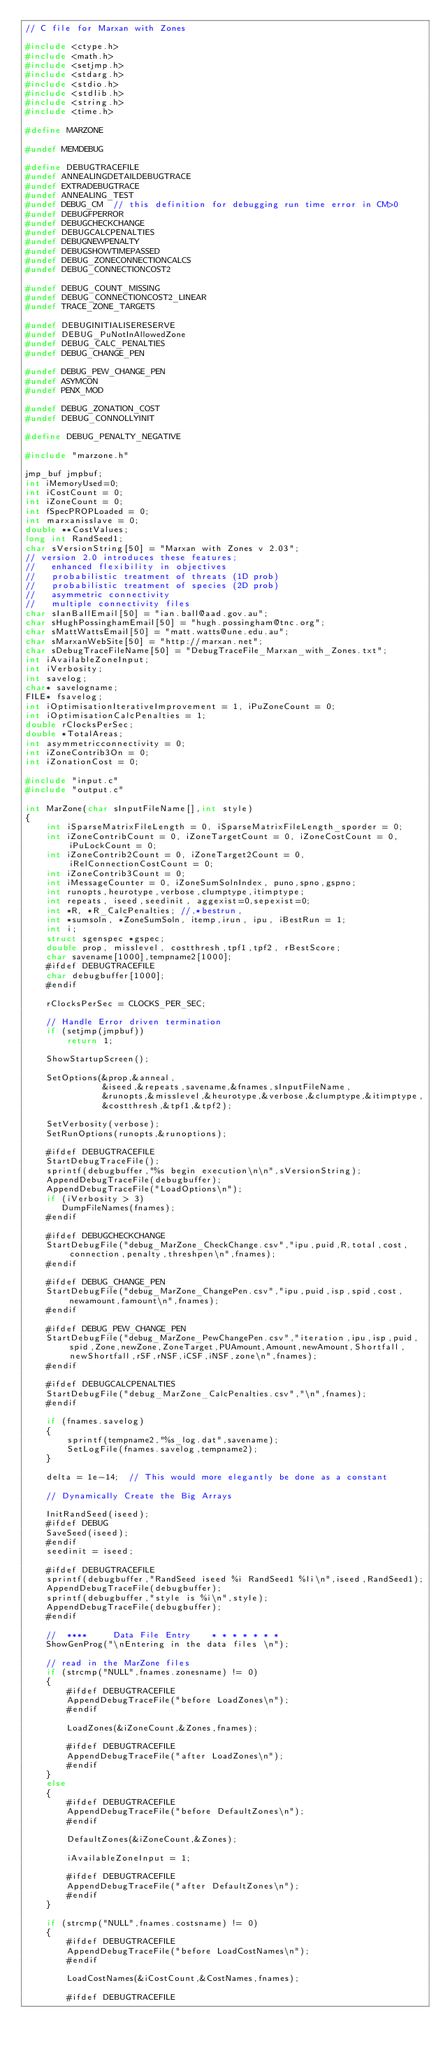Convert code to text. <code><loc_0><loc_0><loc_500><loc_500><_C_>// C file for Marxan with Zones

#include <ctype.h>
#include <math.h>
#include <setjmp.h>
#include <stdarg.h>
#include <stdio.h>
#include <stdlib.h>
#include <string.h>
#include <time.h>

#define MARZONE

#undef MEMDEBUG

#define DEBUGTRACEFILE
#undef ANNEALINGDETAILDEBUGTRACE
#undef EXTRADEBUGTRACE
#undef ANNEALING_TEST
#undef DEBUG_CM  // this definition for debugging run time error in CM>0
#undef DEBUGFPERROR
#undef DEBUGCHECKCHANGE
#undef DEBUGCALCPENALTIES
#undef DEBUGNEWPENALTY
#undef DEBUGSHOWTIMEPASSED
#undef DEBUG_ZONECONNECTIONCALCS
#undef DEBUG_CONNECTIONCOST2

#undef DEBUG_COUNT_MISSING
#undef DEBUG_CONNECTIONCOST2_LINEAR
#undef TRACE_ZONE_TARGETS

#undef DEBUGINITIALISERESERVE
#undef DEBUG_PuNotInAllowedZone
#undef DEBUG_CALC_PENALTIES
#undef DEBUG_CHANGE_PEN

#undef DEBUG_PEW_CHANGE_PEN
#undef ASYMCON
#undef PENX_MOD

#undef DEBUG_ZONATION_COST
#undef DEBUG_CONNOLLYINIT

#define DEBUG_PENALTY_NEGATIVE

#include "marzone.h"

jmp_buf jmpbuf;
int iMemoryUsed=0;
int iCostCount = 0;
int iZoneCount = 0;
int fSpecPROPLoaded = 0;
int marxanisslave = 0;
double **CostValues;
long int RandSeed1;
char sVersionString[50] = "Marxan with Zones v 2.03";
// version 2.0 introduces these features;
//   enhanced flexibility in objectives
//   probabilistic treatment of threats (1D prob)
//   probabilistic treatment of species (2D prob)
//   asymmetric connectivity
//   multiple connectivity files
char sIanBallEmail[50] = "ian.ball@aad.gov.au";
char sHughPossinghamEmail[50] = "hugh.possingham@tnc.org";
char sMattWattsEmail[50] = "matt.watts@une.edu.au";
char sMarxanWebSite[50] = "http://marxan.net";
char sDebugTraceFileName[50] = "DebugTraceFile_Marxan_with_Zones.txt";
int iAvailableZoneInput;
int iVerbosity;
int savelog;
char* savelogname;
FILE* fsavelog;
int iOptimisationIterativeImprovement = 1, iPuZoneCount = 0;
int iOptimisationCalcPenalties = 1;
double rClocksPerSec;
double *TotalAreas;
int asymmetricconnectivity = 0;
int iZoneContrib3On = 0;
int iZonationCost = 0;

#include "input.c"
#include "output.c"

int MarZone(char sInputFileName[],int style)
{
    int iSparseMatrixFileLength = 0, iSparseMatrixFileLength_sporder = 0;
    int iZoneContribCount = 0, iZoneTargetCount = 0, iZoneCostCount = 0, iPuLockCount = 0;
    int iZoneContrib2Count = 0, iZoneTarget2Count = 0, iRelConnectionCostCount = 0;
    int iZoneContrib3Count = 0;
    int iMessageCounter = 0, iZoneSumSolnIndex, puno,spno,gspno;
    int runopts,heurotype,verbose,clumptype,itimptype;
    int repeats, iseed,seedinit, aggexist=0,sepexist=0;
    int *R, *R_CalcPenalties; //,*bestrun,
    int *sumsoln, *ZoneSumSoln, itemp,irun, ipu, iBestRun = 1;
    int i;
    struct sgenspec *gspec;
    double prop, misslevel, costthresh,tpf1,tpf2, rBestScore;
    char savename[1000],tempname2[1000];
    #ifdef DEBUGTRACEFILE
    char debugbuffer[1000];
    #endif

    rClocksPerSec = CLOCKS_PER_SEC;

    // Handle Error driven termination
    if (setjmp(jmpbuf))
        return 1;

    ShowStartupScreen();

    SetOptions(&prop,&anneal,
               &iseed,&repeats,savename,&fnames,sInputFileName,
               &runopts,&misslevel,&heurotype,&verbose,&clumptype,&itimptype,
               &costthresh,&tpf1,&tpf2);

    SetVerbosity(verbose);
    SetRunOptions(runopts,&runoptions);

    #ifdef DEBUGTRACEFILE
    StartDebugTraceFile();
    sprintf(debugbuffer,"%s begin execution\n\n",sVersionString);
    AppendDebugTraceFile(debugbuffer);
    AppendDebugTraceFile("LoadOptions\n");
    if (iVerbosity > 3)
       DumpFileNames(fnames);
    #endif

    #ifdef DEBUGCHECKCHANGE
    StartDebugFile("debug_MarZone_CheckChange.csv","ipu,puid,R,total,cost,connection,penalty,threshpen\n",fnames);
    #endif

    #ifdef DEBUG_CHANGE_PEN
    StartDebugFile("debug_MarZone_ChangePen.csv","ipu,puid,isp,spid,cost,newamount,famount\n",fnames);
    #endif

    #ifdef DEBUG_PEW_CHANGE_PEN
    StartDebugFile("debug_MarZone_PewChangePen.csv","iteration,ipu,isp,puid,spid,Zone,newZone,ZoneTarget,PUAmount,Amount,newAmount,Shortfall,newShortfall,rSF,rNSF,iCSF,iNSF,zone\n",fnames);
    #endif

    #ifdef DEBUGCALCPENALTIES
    StartDebugFile("debug_MarZone_CalcPenalties.csv","\n",fnames);
    #endif

    if (fnames.savelog)
    {
        sprintf(tempname2,"%s_log.dat",savename);
        SetLogFile(fnames.savelog,tempname2);
    }

    delta = 1e-14;  // This would more elegantly be done as a constant

    // Dynamically Create the Big Arrays

    InitRandSeed(iseed);
    #ifdef DEBUG
    SaveSeed(iseed);
    #endif
    seedinit = iseed;

    #ifdef DEBUGTRACEFILE
    sprintf(debugbuffer,"RandSeed iseed %i RandSeed1 %li\n",iseed,RandSeed1);
    AppendDebugTraceFile(debugbuffer);
    sprintf(debugbuffer,"style is %i\n",style);
    AppendDebugTraceFile(debugbuffer);
    #endif

    //  ****     Data File Entry    * * * * * * *
    ShowGenProg("\nEntering in the data files \n");

    // read in the MarZone files
    if (strcmp("NULL",fnames.zonesname) != 0)
    {
        #ifdef DEBUGTRACEFILE
        AppendDebugTraceFile("before LoadZones\n");
        #endif

        LoadZones(&iZoneCount,&Zones,fnames);

        #ifdef DEBUGTRACEFILE
        AppendDebugTraceFile("after LoadZones\n");
        #endif
    }
    else
    {
        #ifdef DEBUGTRACEFILE
        AppendDebugTraceFile("before DefaultZones\n");
        #endif

        DefaultZones(&iZoneCount,&Zones);

        iAvailableZoneInput = 1;

        #ifdef DEBUGTRACEFILE
        AppendDebugTraceFile("after DefaultZones\n");
        #endif
    }

    if (strcmp("NULL",fnames.costsname) != 0)
    {
        #ifdef DEBUGTRACEFILE
        AppendDebugTraceFile("before LoadCostNames\n");
        #endif

        LoadCostNames(&iCostCount,&CostNames,fnames);

        #ifdef DEBUGTRACEFILE</code> 